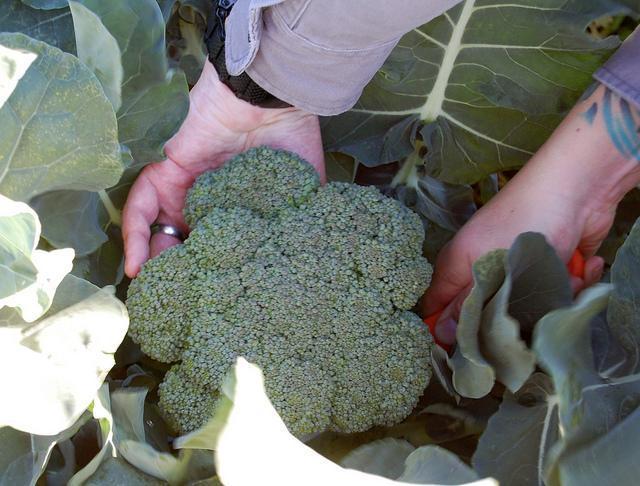How many people are in the picture?
Give a very brief answer. 2. How many dogs are there left to the lady?
Give a very brief answer. 0. 